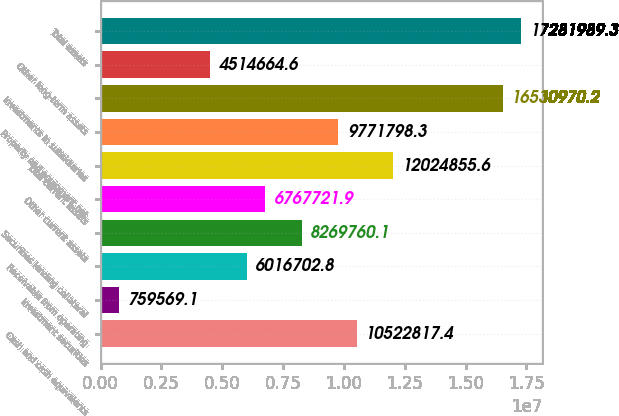Convert chart. <chart><loc_0><loc_0><loc_500><loc_500><bar_chart><fcel>Cash and cash equivalents<fcel>Investment securities<fcel>Receivable from operating<fcel>Securities lending collateral<fcel>Other current assets<fcel>Total current assets<fcel>Property and equipment net<fcel>Investments in subsidiaries<fcel>Other long-term assets<fcel>Total assets<nl><fcel>1.05228e+07<fcel>759569<fcel>6.0167e+06<fcel>8.26976e+06<fcel>6.76772e+06<fcel>1.20249e+07<fcel>9.7718e+06<fcel>1.6531e+07<fcel>4.51466e+06<fcel>1.7282e+07<nl></chart> 